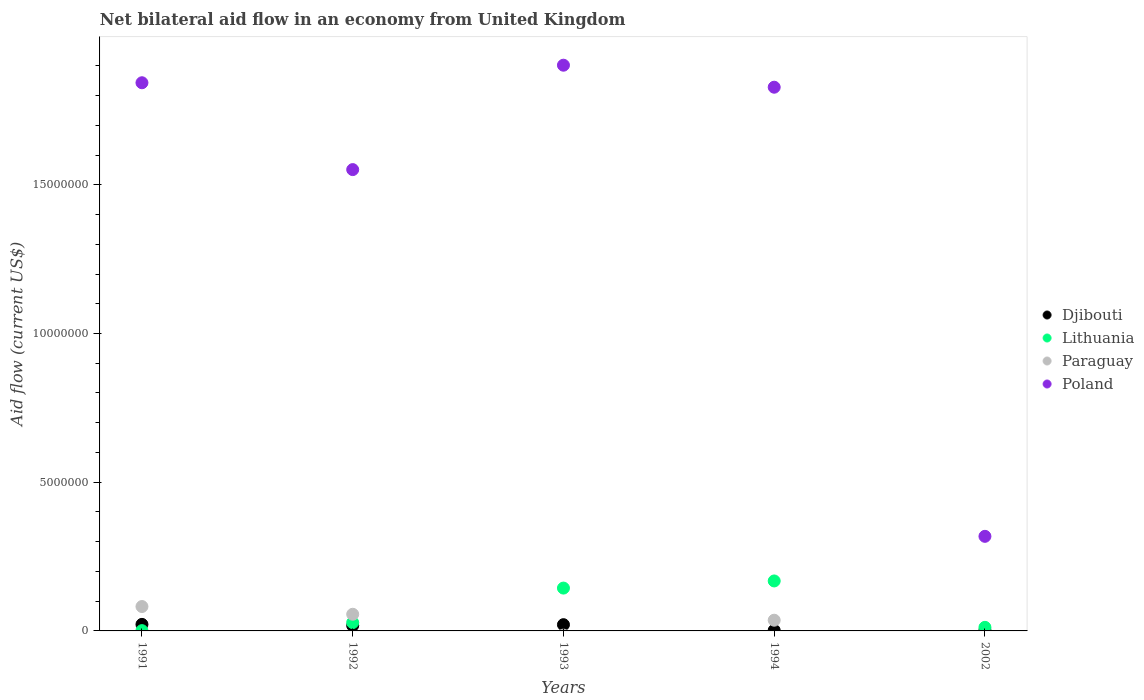How many different coloured dotlines are there?
Your answer should be compact. 4. What is the net bilateral aid flow in Paraguay in 1992?
Offer a terse response. 5.60e+05. Across all years, what is the maximum net bilateral aid flow in Djibouti?
Your answer should be compact. 2.20e+05. In which year was the net bilateral aid flow in Djibouti maximum?
Give a very brief answer. 1991. What is the total net bilateral aid flow in Paraguay in the graph?
Give a very brief answer. 1.74e+06. What is the difference between the net bilateral aid flow in Djibouti in 1993 and that in 1994?
Your answer should be compact. 1.90e+05. What is the difference between the net bilateral aid flow in Lithuania in 1993 and the net bilateral aid flow in Djibouti in 2002?
Ensure brevity in your answer.  1.42e+06. What is the average net bilateral aid flow in Poland per year?
Keep it short and to the point. 1.49e+07. In the year 1991, what is the difference between the net bilateral aid flow in Djibouti and net bilateral aid flow in Lithuania?
Your answer should be compact. 2.10e+05. In how many years, is the net bilateral aid flow in Djibouti greater than 4000000 US$?
Your answer should be compact. 0. What is the ratio of the net bilateral aid flow in Poland in 1991 to that in 2002?
Keep it short and to the point. 5.8. Is the net bilateral aid flow in Djibouti in 1991 less than that in 2002?
Your answer should be very brief. No. Is the difference between the net bilateral aid flow in Djibouti in 1994 and 2002 greater than the difference between the net bilateral aid flow in Lithuania in 1994 and 2002?
Your answer should be very brief. No. What is the difference between the highest and the lowest net bilateral aid flow in Poland?
Keep it short and to the point. 1.58e+07. In how many years, is the net bilateral aid flow in Lithuania greater than the average net bilateral aid flow in Lithuania taken over all years?
Provide a short and direct response. 2. Does the net bilateral aid flow in Paraguay monotonically increase over the years?
Ensure brevity in your answer.  No. Is the net bilateral aid flow in Lithuania strictly less than the net bilateral aid flow in Djibouti over the years?
Your response must be concise. No. How many dotlines are there?
Offer a very short reply. 4. How many years are there in the graph?
Give a very brief answer. 5. What is the difference between two consecutive major ticks on the Y-axis?
Make the answer very short. 5.00e+06. Does the graph contain any zero values?
Your response must be concise. Yes. Does the graph contain grids?
Your response must be concise. No. How are the legend labels stacked?
Offer a very short reply. Vertical. What is the title of the graph?
Keep it short and to the point. Net bilateral aid flow in an economy from United Kingdom. What is the Aid flow (current US$) of Djibouti in 1991?
Your answer should be compact. 2.20e+05. What is the Aid flow (current US$) in Paraguay in 1991?
Offer a terse response. 8.20e+05. What is the Aid flow (current US$) of Poland in 1991?
Your answer should be compact. 1.84e+07. What is the Aid flow (current US$) of Djibouti in 1992?
Provide a succinct answer. 1.80e+05. What is the Aid flow (current US$) of Lithuania in 1992?
Your response must be concise. 2.80e+05. What is the Aid flow (current US$) of Paraguay in 1992?
Make the answer very short. 5.60e+05. What is the Aid flow (current US$) in Poland in 1992?
Offer a terse response. 1.55e+07. What is the Aid flow (current US$) in Lithuania in 1993?
Your answer should be very brief. 1.44e+06. What is the Aid flow (current US$) in Poland in 1993?
Your response must be concise. 1.90e+07. What is the Aid flow (current US$) in Djibouti in 1994?
Offer a very short reply. 2.00e+04. What is the Aid flow (current US$) in Lithuania in 1994?
Provide a short and direct response. 1.68e+06. What is the Aid flow (current US$) in Paraguay in 1994?
Your answer should be compact. 3.60e+05. What is the Aid flow (current US$) in Poland in 1994?
Provide a succinct answer. 1.83e+07. What is the Aid flow (current US$) of Djibouti in 2002?
Ensure brevity in your answer.  2.00e+04. What is the Aid flow (current US$) in Lithuania in 2002?
Ensure brevity in your answer.  1.20e+05. What is the Aid flow (current US$) in Poland in 2002?
Give a very brief answer. 3.18e+06. Across all years, what is the maximum Aid flow (current US$) in Djibouti?
Your response must be concise. 2.20e+05. Across all years, what is the maximum Aid flow (current US$) in Lithuania?
Make the answer very short. 1.68e+06. Across all years, what is the maximum Aid flow (current US$) of Paraguay?
Offer a very short reply. 8.20e+05. Across all years, what is the maximum Aid flow (current US$) in Poland?
Your response must be concise. 1.90e+07. Across all years, what is the minimum Aid flow (current US$) of Djibouti?
Your answer should be very brief. 2.00e+04. Across all years, what is the minimum Aid flow (current US$) of Paraguay?
Your answer should be very brief. 0. Across all years, what is the minimum Aid flow (current US$) of Poland?
Your answer should be compact. 3.18e+06. What is the total Aid flow (current US$) in Djibouti in the graph?
Provide a succinct answer. 6.50e+05. What is the total Aid flow (current US$) in Lithuania in the graph?
Keep it short and to the point. 3.53e+06. What is the total Aid flow (current US$) of Paraguay in the graph?
Keep it short and to the point. 1.74e+06. What is the total Aid flow (current US$) of Poland in the graph?
Give a very brief answer. 7.44e+07. What is the difference between the Aid flow (current US$) of Lithuania in 1991 and that in 1992?
Ensure brevity in your answer.  -2.70e+05. What is the difference between the Aid flow (current US$) in Paraguay in 1991 and that in 1992?
Offer a very short reply. 2.60e+05. What is the difference between the Aid flow (current US$) in Poland in 1991 and that in 1992?
Offer a terse response. 2.92e+06. What is the difference between the Aid flow (current US$) of Djibouti in 1991 and that in 1993?
Your answer should be compact. 10000. What is the difference between the Aid flow (current US$) in Lithuania in 1991 and that in 1993?
Make the answer very short. -1.43e+06. What is the difference between the Aid flow (current US$) in Poland in 1991 and that in 1993?
Make the answer very short. -5.90e+05. What is the difference between the Aid flow (current US$) in Djibouti in 1991 and that in 1994?
Give a very brief answer. 2.00e+05. What is the difference between the Aid flow (current US$) of Lithuania in 1991 and that in 1994?
Offer a very short reply. -1.67e+06. What is the difference between the Aid flow (current US$) of Djibouti in 1991 and that in 2002?
Offer a very short reply. 2.00e+05. What is the difference between the Aid flow (current US$) in Lithuania in 1991 and that in 2002?
Give a very brief answer. -1.10e+05. What is the difference between the Aid flow (current US$) of Poland in 1991 and that in 2002?
Provide a succinct answer. 1.52e+07. What is the difference between the Aid flow (current US$) in Djibouti in 1992 and that in 1993?
Give a very brief answer. -3.00e+04. What is the difference between the Aid flow (current US$) of Lithuania in 1992 and that in 1993?
Offer a terse response. -1.16e+06. What is the difference between the Aid flow (current US$) of Poland in 1992 and that in 1993?
Provide a short and direct response. -3.51e+06. What is the difference between the Aid flow (current US$) of Djibouti in 1992 and that in 1994?
Offer a very short reply. 1.60e+05. What is the difference between the Aid flow (current US$) of Lithuania in 1992 and that in 1994?
Make the answer very short. -1.40e+06. What is the difference between the Aid flow (current US$) in Poland in 1992 and that in 1994?
Provide a short and direct response. -2.77e+06. What is the difference between the Aid flow (current US$) in Lithuania in 1992 and that in 2002?
Offer a terse response. 1.60e+05. What is the difference between the Aid flow (current US$) of Poland in 1992 and that in 2002?
Your response must be concise. 1.23e+07. What is the difference between the Aid flow (current US$) in Lithuania in 1993 and that in 1994?
Make the answer very short. -2.40e+05. What is the difference between the Aid flow (current US$) of Poland in 1993 and that in 1994?
Provide a short and direct response. 7.40e+05. What is the difference between the Aid flow (current US$) in Lithuania in 1993 and that in 2002?
Your answer should be very brief. 1.32e+06. What is the difference between the Aid flow (current US$) in Poland in 1993 and that in 2002?
Provide a short and direct response. 1.58e+07. What is the difference between the Aid flow (current US$) of Djibouti in 1994 and that in 2002?
Provide a short and direct response. 0. What is the difference between the Aid flow (current US$) of Lithuania in 1994 and that in 2002?
Provide a short and direct response. 1.56e+06. What is the difference between the Aid flow (current US$) of Poland in 1994 and that in 2002?
Ensure brevity in your answer.  1.51e+07. What is the difference between the Aid flow (current US$) in Djibouti in 1991 and the Aid flow (current US$) in Paraguay in 1992?
Make the answer very short. -3.40e+05. What is the difference between the Aid flow (current US$) in Djibouti in 1991 and the Aid flow (current US$) in Poland in 1992?
Make the answer very short. -1.53e+07. What is the difference between the Aid flow (current US$) in Lithuania in 1991 and the Aid flow (current US$) in Paraguay in 1992?
Give a very brief answer. -5.50e+05. What is the difference between the Aid flow (current US$) in Lithuania in 1991 and the Aid flow (current US$) in Poland in 1992?
Your answer should be very brief. -1.55e+07. What is the difference between the Aid flow (current US$) of Paraguay in 1991 and the Aid flow (current US$) of Poland in 1992?
Offer a terse response. -1.47e+07. What is the difference between the Aid flow (current US$) in Djibouti in 1991 and the Aid flow (current US$) in Lithuania in 1993?
Offer a very short reply. -1.22e+06. What is the difference between the Aid flow (current US$) in Djibouti in 1991 and the Aid flow (current US$) in Poland in 1993?
Make the answer very short. -1.88e+07. What is the difference between the Aid flow (current US$) in Lithuania in 1991 and the Aid flow (current US$) in Poland in 1993?
Make the answer very short. -1.90e+07. What is the difference between the Aid flow (current US$) in Paraguay in 1991 and the Aid flow (current US$) in Poland in 1993?
Make the answer very short. -1.82e+07. What is the difference between the Aid flow (current US$) of Djibouti in 1991 and the Aid flow (current US$) of Lithuania in 1994?
Make the answer very short. -1.46e+06. What is the difference between the Aid flow (current US$) of Djibouti in 1991 and the Aid flow (current US$) of Poland in 1994?
Offer a terse response. -1.81e+07. What is the difference between the Aid flow (current US$) of Lithuania in 1991 and the Aid flow (current US$) of Paraguay in 1994?
Your answer should be compact. -3.50e+05. What is the difference between the Aid flow (current US$) in Lithuania in 1991 and the Aid flow (current US$) in Poland in 1994?
Your answer should be compact. -1.83e+07. What is the difference between the Aid flow (current US$) of Paraguay in 1991 and the Aid flow (current US$) of Poland in 1994?
Your answer should be compact. -1.75e+07. What is the difference between the Aid flow (current US$) of Djibouti in 1991 and the Aid flow (current US$) of Poland in 2002?
Provide a short and direct response. -2.96e+06. What is the difference between the Aid flow (current US$) of Lithuania in 1991 and the Aid flow (current US$) of Poland in 2002?
Make the answer very short. -3.17e+06. What is the difference between the Aid flow (current US$) of Paraguay in 1991 and the Aid flow (current US$) of Poland in 2002?
Offer a very short reply. -2.36e+06. What is the difference between the Aid flow (current US$) of Djibouti in 1992 and the Aid flow (current US$) of Lithuania in 1993?
Provide a short and direct response. -1.26e+06. What is the difference between the Aid flow (current US$) of Djibouti in 1992 and the Aid flow (current US$) of Poland in 1993?
Keep it short and to the point. -1.88e+07. What is the difference between the Aid flow (current US$) of Lithuania in 1992 and the Aid flow (current US$) of Poland in 1993?
Provide a succinct answer. -1.87e+07. What is the difference between the Aid flow (current US$) in Paraguay in 1992 and the Aid flow (current US$) in Poland in 1993?
Give a very brief answer. -1.85e+07. What is the difference between the Aid flow (current US$) in Djibouti in 1992 and the Aid flow (current US$) in Lithuania in 1994?
Keep it short and to the point. -1.50e+06. What is the difference between the Aid flow (current US$) in Djibouti in 1992 and the Aid flow (current US$) in Paraguay in 1994?
Offer a very short reply. -1.80e+05. What is the difference between the Aid flow (current US$) of Djibouti in 1992 and the Aid flow (current US$) of Poland in 1994?
Give a very brief answer. -1.81e+07. What is the difference between the Aid flow (current US$) in Lithuania in 1992 and the Aid flow (current US$) in Poland in 1994?
Provide a succinct answer. -1.80e+07. What is the difference between the Aid flow (current US$) in Paraguay in 1992 and the Aid flow (current US$) in Poland in 1994?
Offer a terse response. -1.77e+07. What is the difference between the Aid flow (current US$) in Djibouti in 1992 and the Aid flow (current US$) in Lithuania in 2002?
Your answer should be very brief. 6.00e+04. What is the difference between the Aid flow (current US$) in Djibouti in 1992 and the Aid flow (current US$) in Poland in 2002?
Offer a very short reply. -3.00e+06. What is the difference between the Aid flow (current US$) in Lithuania in 1992 and the Aid flow (current US$) in Poland in 2002?
Offer a terse response. -2.90e+06. What is the difference between the Aid flow (current US$) of Paraguay in 1992 and the Aid flow (current US$) of Poland in 2002?
Your response must be concise. -2.62e+06. What is the difference between the Aid flow (current US$) of Djibouti in 1993 and the Aid flow (current US$) of Lithuania in 1994?
Keep it short and to the point. -1.47e+06. What is the difference between the Aid flow (current US$) in Djibouti in 1993 and the Aid flow (current US$) in Poland in 1994?
Ensure brevity in your answer.  -1.81e+07. What is the difference between the Aid flow (current US$) in Lithuania in 1993 and the Aid flow (current US$) in Paraguay in 1994?
Your response must be concise. 1.08e+06. What is the difference between the Aid flow (current US$) of Lithuania in 1993 and the Aid flow (current US$) of Poland in 1994?
Make the answer very short. -1.68e+07. What is the difference between the Aid flow (current US$) of Djibouti in 1993 and the Aid flow (current US$) of Lithuania in 2002?
Your answer should be compact. 9.00e+04. What is the difference between the Aid flow (current US$) in Djibouti in 1993 and the Aid flow (current US$) in Poland in 2002?
Offer a very short reply. -2.97e+06. What is the difference between the Aid flow (current US$) in Lithuania in 1993 and the Aid flow (current US$) in Poland in 2002?
Keep it short and to the point. -1.74e+06. What is the difference between the Aid flow (current US$) of Djibouti in 1994 and the Aid flow (current US$) of Poland in 2002?
Your answer should be very brief. -3.16e+06. What is the difference between the Aid flow (current US$) in Lithuania in 1994 and the Aid flow (current US$) in Poland in 2002?
Offer a terse response. -1.50e+06. What is the difference between the Aid flow (current US$) in Paraguay in 1994 and the Aid flow (current US$) in Poland in 2002?
Make the answer very short. -2.82e+06. What is the average Aid flow (current US$) of Djibouti per year?
Your answer should be very brief. 1.30e+05. What is the average Aid flow (current US$) of Lithuania per year?
Your answer should be compact. 7.06e+05. What is the average Aid flow (current US$) in Paraguay per year?
Your answer should be very brief. 3.48e+05. What is the average Aid flow (current US$) in Poland per year?
Your answer should be compact. 1.49e+07. In the year 1991, what is the difference between the Aid flow (current US$) in Djibouti and Aid flow (current US$) in Paraguay?
Your answer should be compact. -6.00e+05. In the year 1991, what is the difference between the Aid flow (current US$) in Djibouti and Aid flow (current US$) in Poland?
Ensure brevity in your answer.  -1.82e+07. In the year 1991, what is the difference between the Aid flow (current US$) in Lithuania and Aid flow (current US$) in Paraguay?
Keep it short and to the point. -8.10e+05. In the year 1991, what is the difference between the Aid flow (current US$) of Lithuania and Aid flow (current US$) of Poland?
Provide a short and direct response. -1.84e+07. In the year 1991, what is the difference between the Aid flow (current US$) in Paraguay and Aid flow (current US$) in Poland?
Your response must be concise. -1.76e+07. In the year 1992, what is the difference between the Aid flow (current US$) of Djibouti and Aid flow (current US$) of Paraguay?
Give a very brief answer. -3.80e+05. In the year 1992, what is the difference between the Aid flow (current US$) of Djibouti and Aid flow (current US$) of Poland?
Your answer should be compact. -1.53e+07. In the year 1992, what is the difference between the Aid flow (current US$) of Lithuania and Aid flow (current US$) of Paraguay?
Keep it short and to the point. -2.80e+05. In the year 1992, what is the difference between the Aid flow (current US$) of Lithuania and Aid flow (current US$) of Poland?
Provide a short and direct response. -1.52e+07. In the year 1992, what is the difference between the Aid flow (current US$) of Paraguay and Aid flow (current US$) of Poland?
Offer a terse response. -1.50e+07. In the year 1993, what is the difference between the Aid flow (current US$) of Djibouti and Aid flow (current US$) of Lithuania?
Offer a terse response. -1.23e+06. In the year 1993, what is the difference between the Aid flow (current US$) in Djibouti and Aid flow (current US$) in Poland?
Provide a succinct answer. -1.88e+07. In the year 1993, what is the difference between the Aid flow (current US$) in Lithuania and Aid flow (current US$) in Poland?
Your response must be concise. -1.76e+07. In the year 1994, what is the difference between the Aid flow (current US$) of Djibouti and Aid flow (current US$) of Lithuania?
Make the answer very short. -1.66e+06. In the year 1994, what is the difference between the Aid flow (current US$) of Djibouti and Aid flow (current US$) of Poland?
Your response must be concise. -1.83e+07. In the year 1994, what is the difference between the Aid flow (current US$) of Lithuania and Aid flow (current US$) of Paraguay?
Give a very brief answer. 1.32e+06. In the year 1994, what is the difference between the Aid flow (current US$) in Lithuania and Aid flow (current US$) in Poland?
Keep it short and to the point. -1.66e+07. In the year 1994, what is the difference between the Aid flow (current US$) of Paraguay and Aid flow (current US$) of Poland?
Offer a very short reply. -1.79e+07. In the year 2002, what is the difference between the Aid flow (current US$) in Djibouti and Aid flow (current US$) in Poland?
Make the answer very short. -3.16e+06. In the year 2002, what is the difference between the Aid flow (current US$) of Lithuania and Aid flow (current US$) of Poland?
Your response must be concise. -3.06e+06. What is the ratio of the Aid flow (current US$) of Djibouti in 1991 to that in 1992?
Keep it short and to the point. 1.22. What is the ratio of the Aid flow (current US$) in Lithuania in 1991 to that in 1992?
Provide a short and direct response. 0.04. What is the ratio of the Aid flow (current US$) in Paraguay in 1991 to that in 1992?
Your answer should be very brief. 1.46. What is the ratio of the Aid flow (current US$) of Poland in 1991 to that in 1992?
Make the answer very short. 1.19. What is the ratio of the Aid flow (current US$) of Djibouti in 1991 to that in 1993?
Offer a terse response. 1.05. What is the ratio of the Aid flow (current US$) in Lithuania in 1991 to that in 1993?
Your response must be concise. 0.01. What is the ratio of the Aid flow (current US$) in Poland in 1991 to that in 1993?
Your answer should be compact. 0.97. What is the ratio of the Aid flow (current US$) in Lithuania in 1991 to that in 1994?
Offer a terse response. 0.01. What is the ratio of the Aid flow (current US$) of Paraguay in 1991 to that in 1994?
Give a very brief answer. 2.28. What is the ratio of the Aid flow (current US$) of Poland in 1991 to that in 1994?
Offer a terse response. 1.01. What is the ratio of the Aid flow (current US$) in Lithuania in 1991 to that in 2002?
Ensure brevity in your answer.  0.08. What is the ratio of the Aid flow (current US$) in Poland in 1991 to that in 2002?
Your response must be concise. 5.8. What is the ratio of the Aid flow (current US$) in Lithuania in 1992 to that in 1993?
Ensure brevity in your answer.  0.19. What is the ratio of the Aid flow (current US$) in Poland in 1992 to that in 1993?
Offer a terse response. 0.82. What is the ratio of the Aid flow (current US$) in Lithuania in 1992 to that in 1994?
Ensure brevity in your answer.  0.17. What is the ratio of the Aid flow (current US$) in Paraguay in 1992 to that in 1994?
Offer a very short reply. 1.56. What is the ratio of the Aid flow (current US$) in Poland in 1992 to that in 1994?
Give a very brief answer. 0.85. What is the ratio of the Aid flow (current US$) in Djibouti in 1992 to that in 2002?
Make the answer very short. 9. What is the ratio of the Aid flow (current US$) in Lithuania in 1992 to that in 2002?
Provide a short and direct response. 2.33. What is the ratio of the Aid flow (current US$) in Poland in 1992 to that in 2002?
Your answer should be very brief. 4.88. What is the ratio of the Aid flow (current US$) in Poland in 1993 to that in 1994?
Keep it short and to the point. 1.04. What is the ratio of the Aid flow (current US$) in Djibouti in 1993 to that in 2002?
Offer a terse response. 10.5. What is the ratio of the Aid flow (current US$) of Lithuania in 1993 to that in 2002?
Keep it short and to the point. 12. What is the ratio of the Aid flow (current US$) of Poland in 1993 to that in 2002?
Make the answer very short. 5.98. What is the ratio of the Aid flow (current US$) in Poland in 1994 to that in 2002?
Ensure brevity in your answer.  5.75. What is the difference between the highest and the second highest Aid flow (current US$) of Paraguay?
Ensure brevity in your answer.  2.60e+05. What is the difference between the highest and the second highest Aid flow (current US$) of Poland?
Your answer should be very brief. 5.90e+05. What is the difference between the highest and the lowest Aid flow (current US$) in Lithuania?
Your answer should be compact. 1.67e+06. What is the difference between the highest and the lowest Aid flow (current US$) in Paraguay?
Keep it short and to the point. 8.20e+05. What is the difference between the highest and the lowest Aid flow (current US$) of Poland?
Make the answer very short. 1.58e+07. 